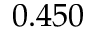Convert formula to latex. <formula><loc_0><loc_0><loc_500><loc_500>0 . 4 5 0</formula> 